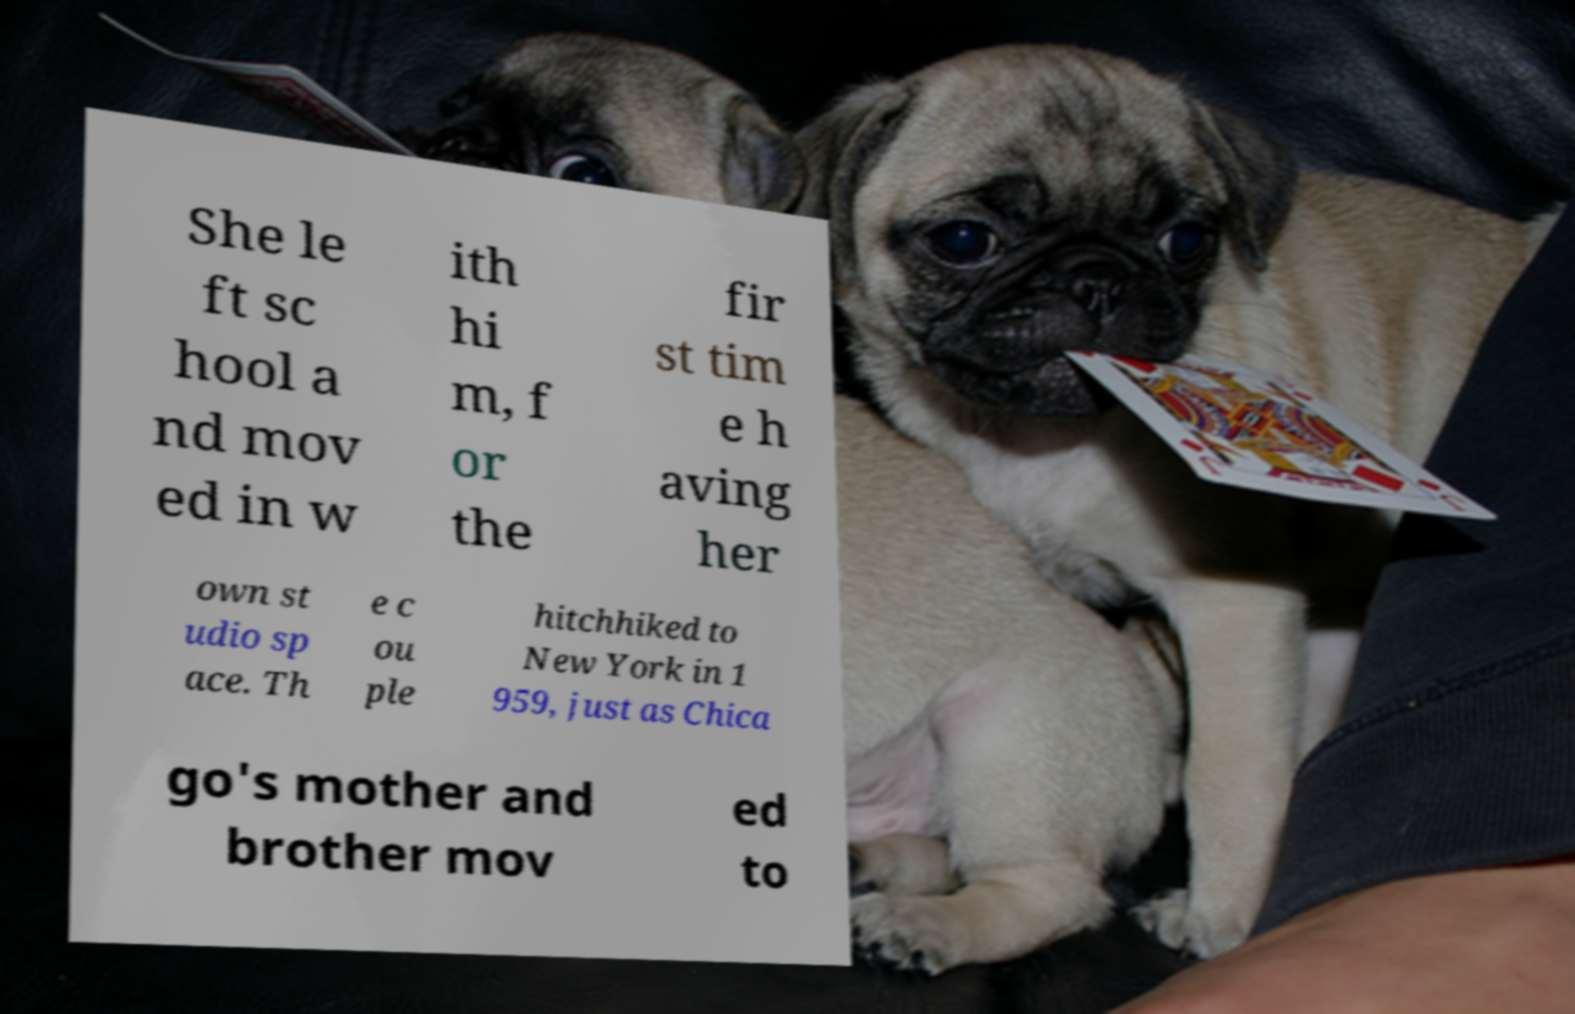There's text embedded in this image that I need extracted. Can you transcribe it verbatim? She le ft sc hool a nd mov ed in w ith hi m, f or the fir st tim e h aving her own st udio sp ace. Th e c ou ple hitchhiked to New York in 1 959, just as Chica go's mother and brother mov ed to 